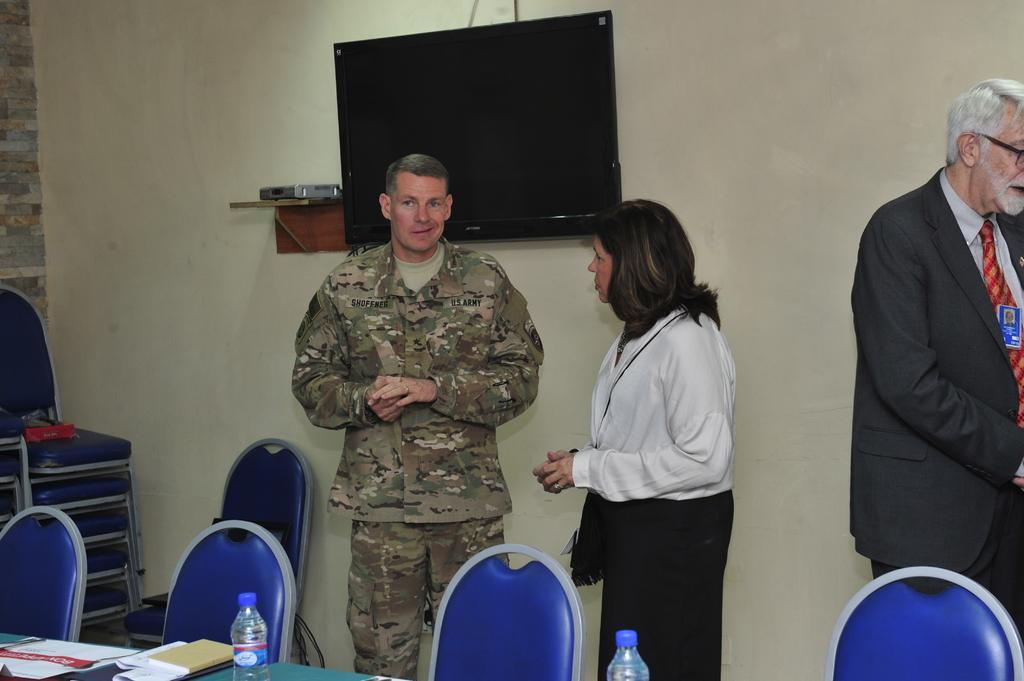Can you describe this image briefly? As we can see in the image there are three people who are standing and at the back there is a tv screen and in front there are chairs and table on which there are water bottles kept. 